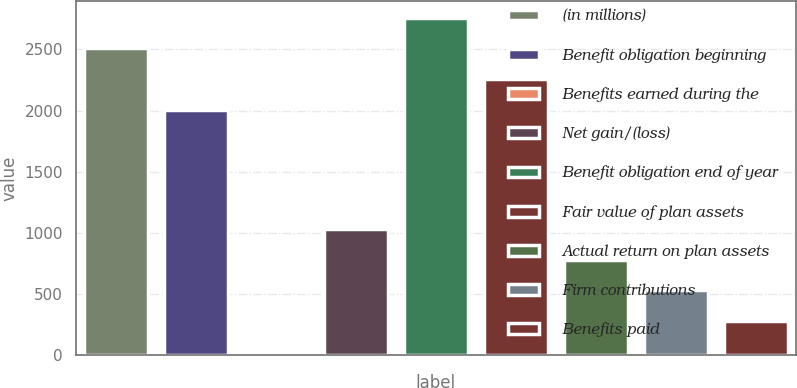Convert chart to OTSL. <chart><loc_0><loc_0><loc_500><loc_500><bar_chart><fcel>(in millions)<fcel>Benefit obligation beginning<fcel>Benefits earned during the<fcel>Net gain/(loss)<fcel>Benefit obligation end of year<fcel>Fair value of plan assets<fcel>Actual return on plan assets<fcel>Firm contributions<fcel>Benefits paid<nl><fcel>2508.2<fcel>2007<fcel>30<fcel>1032.4<fcel>2758.8<fcel>2257.6<fcel>781.8<fcel>531.2<fcel>280.6<nl></chart> 